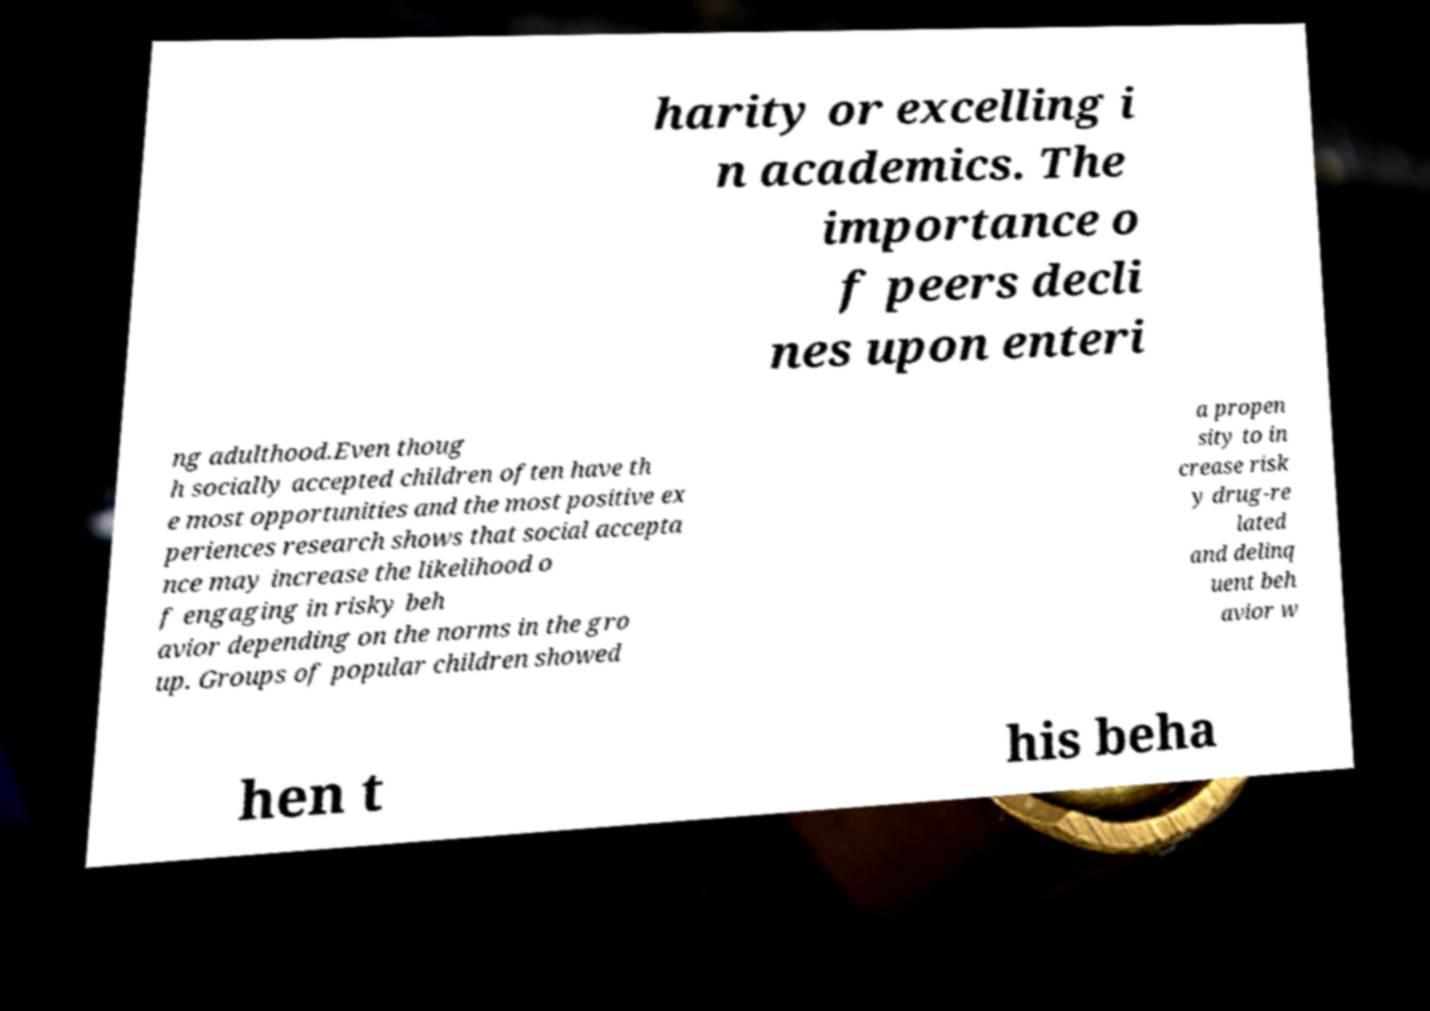For documentation purposes, I need the text within this image transcribed. Could you provide that? harity or excelling i n academics. The importance o f peers decli nes upon enteri ng adulthood.Even thoug h socially accepted children often have th e most opportunities and the most positive ex periences research shows that social accepta nce may increase the likelihood o f engaging in risky beh avior depending on the norms in the gro up. Groups of popular children showed a propen sity to in crease risk y drug-re lated and delinq uent beh avior w hen t his beha 